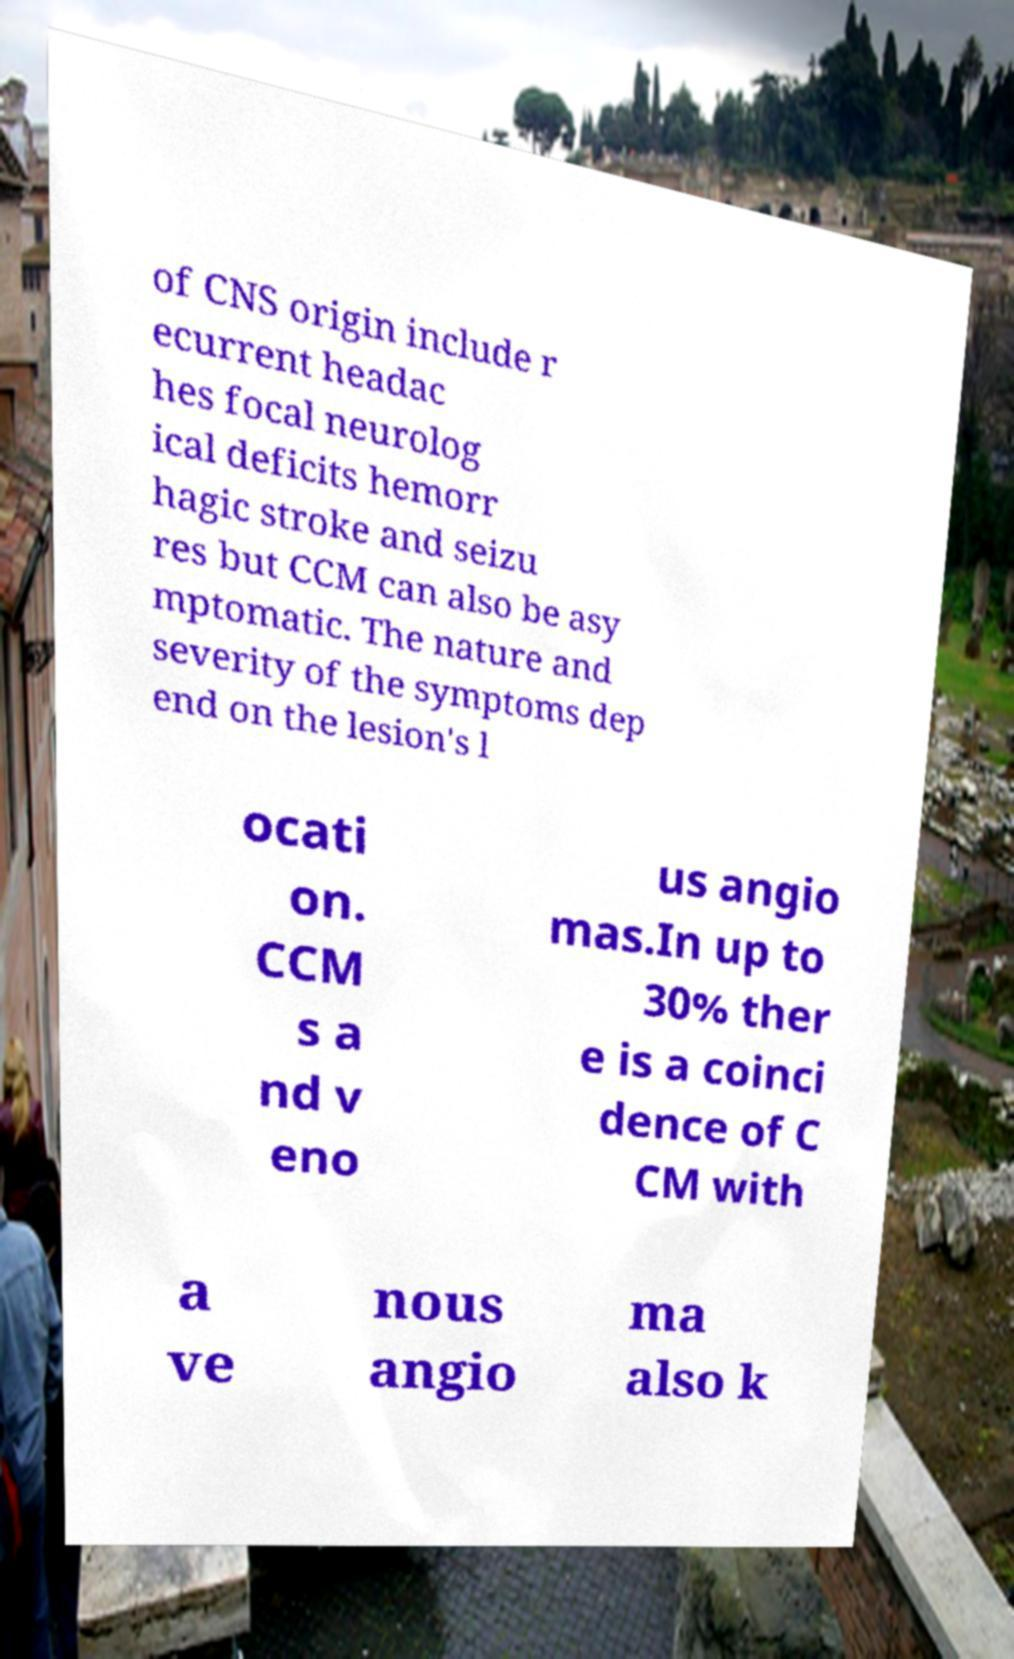What messages or text are displayed in this image? I need them in a readable, typed format. of CNS origin include r ecurrent headac hes focal neurolog ical deficits hemorr hagic stroke and seizu res but CCM can also be asy mptomatic. The nature and severity of the symptoms dep end on the lesion's l ocati on. CCM s a nd v eno us angio mas.In up to 30% ther e is a coinci dence of C CM with a ve nous angio ma also k 